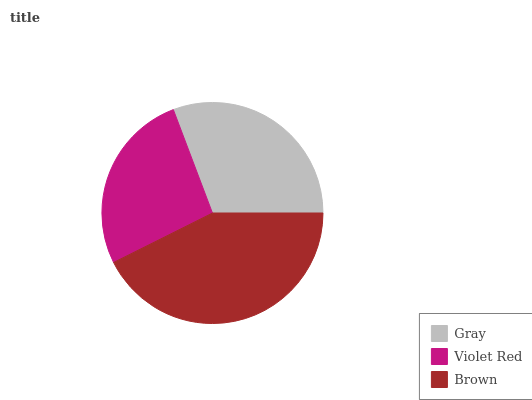Is Violet Red the minimum?
Answer yes or no. Yes. Is Brown the maximum?
Answer yes or no. Yes. Is Brown the minimum?
Answer yes or no. No. Is Violet Red the maximum?
Answer yes or no. No. Is Brown greater than Violet Red?
Answer yes or no. Yes. Is Violet Red less than Brown?
Answer yes or no. Yes. Is Violet Red greater than Brown?
Answer yes or no. No. Is Brown less than Violet Red?
Answer yes or no. No. Is Gray the high median?
Answer yes or no. Yes. Is Gray the low median?
Answer yes or no. Yes. Is Violet Red the high median?
Answer yes or no. No. Is Violet Red the low median?
Answer yes or no. No. 